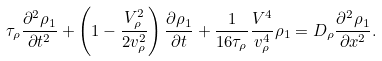<formula> <loc_0><loc_0><loc_500><loc_500>\tau _ { \rho } \frac { \partial ^ { 2 } \rho _ { 1 } } { \partial t ^ { 2 } } + \left ( 1 - \frac { V _ { \rho } ^ { 2 } } { 2 v _ { \rho } ^ { 2 } } \right ) \frac { \partial \rho _ { 1 } } { \partial t } + \frac { 1 } { 1 6 \tau _ { \rho } } \frac { V ^ { 4 } } { v _ { \rho } ^ { 4 } } \rho _ { 1 } = D _ { \rho } \frac { \partial ^ { 2 } \rho _ { 1 } } { \partial x ^ { 2 } } .</formula> 